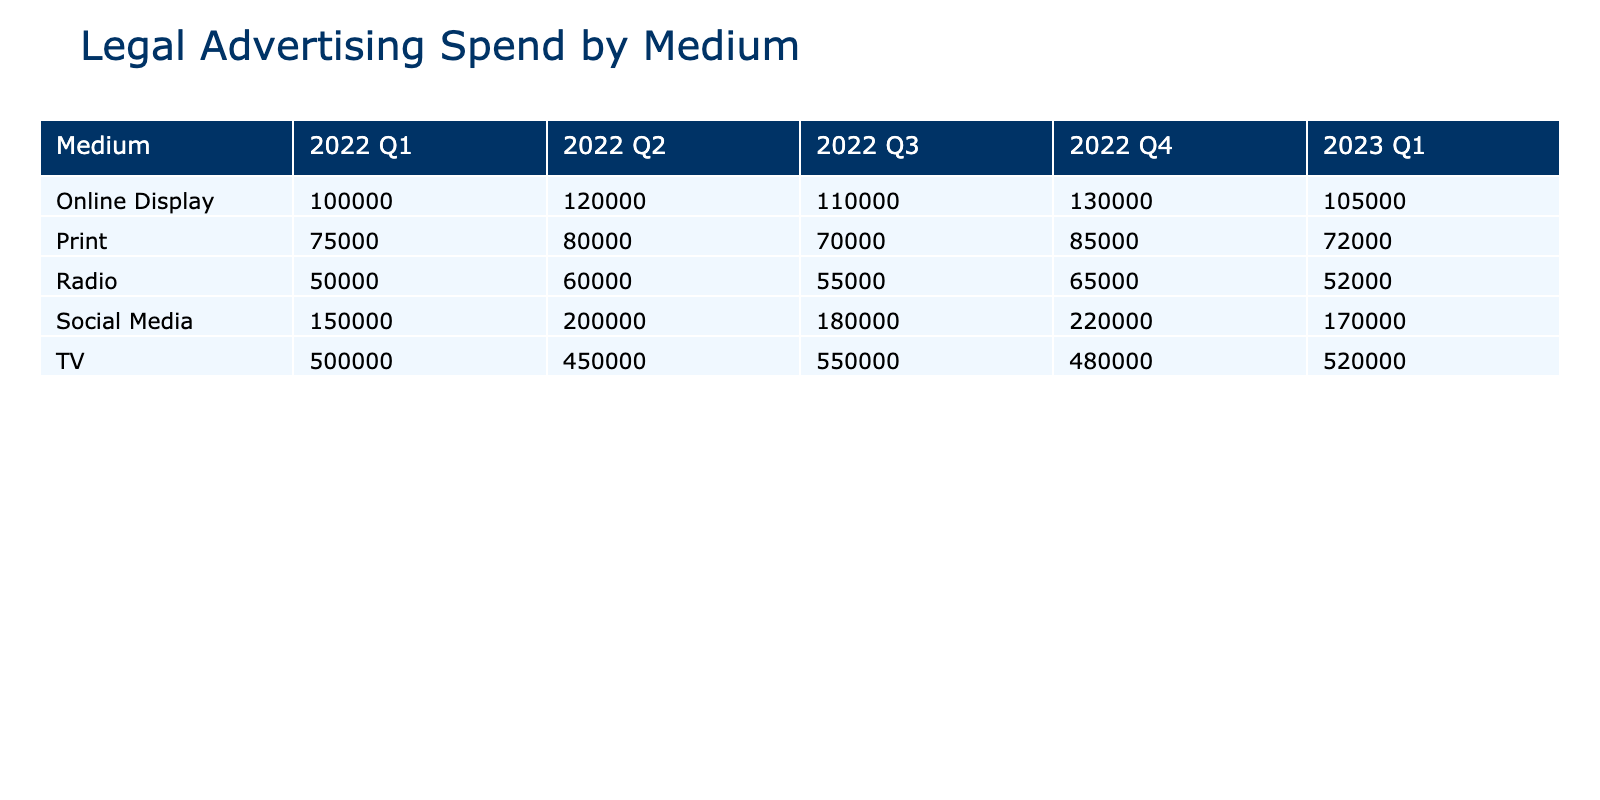What is the total spend on TV advertising in Q1 of 2022? The pivot table shows the spend per medium for each quarter. Under the TV medium for Q1 of 2022, the spend amount is 500,000. As this is the only entry for TV in that quarter, the total is 500,000.
Answer: 500000 Which medium had the highest ROI in Q2 of 2022? The ROI for each medium is listed by quarter. In Q2 of 2022, the ROIs are 2.5 for TV (Baker McKenzie), 3.2 for Social Media (Jones Day), 1.6 for Print (Sidley Austin), 1.9 for Radio (Hogan Lovells), and 2.9 for Online Display (Morgan Lewis). The highest ROI is 3.2 from Social Media.
Answer: Social Media What is the average spend on Print advertising across all years? To find the average spend on Print advertising, we sum the spend amounts for the Print medium: 75,000 (Q1 2022) + 80,000 (Q2 2022) + 70,000 (Q3 2022) + 85,000 (Q4 2022) + 72,000 (Q1 2023) = 382,000. There are 5 entries for Print, thus the average is 382,000 / 5 = 76,400.
Answer: 76400 Did DLA Piper increase its advertising spend from Q1 2022 to Q1 2023? In Q1 2022, DLA Piper's advertising spend was 50,000 (Radio). In Q1 2023, it was 52,000 (also Radio). To determine if it increased, we compare these values. Since 52,000 is greater than 50,000, the spend did increase.
Answer: Yes What is the difference in total spend on Online Display advertising between Q1 and Q4 of 2022? The spend on Online Display in Q1 2022 was 100,000, while in Q4 2022 it was 130,000. To find the difference, we subtract the Q1 value from the Q4 value: 130,000 - 100,000 = 30,000. The total spend difference between these quarters is therefore 30,000.
Answer: 30000 